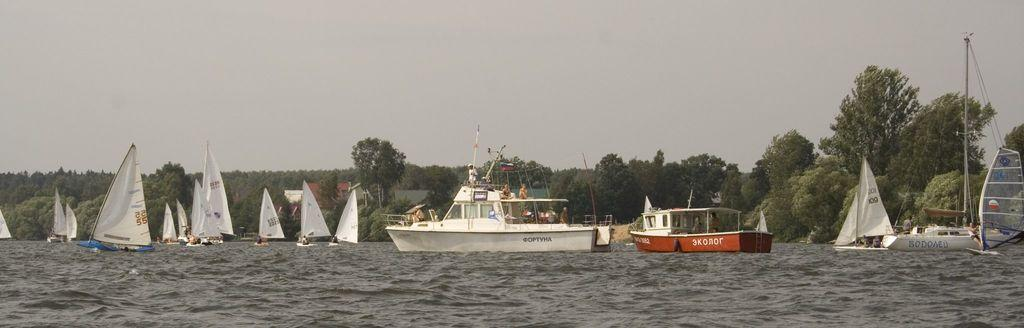What is the main subject of the image? The main subject of the image is many boats. Where are the boats located? The boats are on the water. Are there any people in the boats? Yes, there are people in some of the boats. What can be seen in the background of the image? There are many trees and the sky visible in the background of the image. What type of caption would best describe the image? There is no caption present in the image, so it's not possible to determine the best caption for it. 